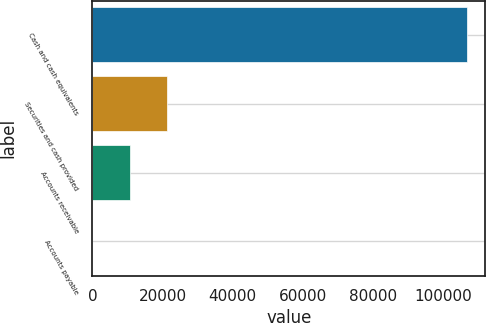Convert chart. <chart><loc_0><loc_0><loc_500><loc_500><bar_chart><fcel>Cash and cash equivalents<fcel>Securities and cash provided<fcel>Accounts receivable<fcel>Accounts payable<nl><fcel>106649<fcel>21338.6<fcel>10674.8<fcel>11<nl></chart> 